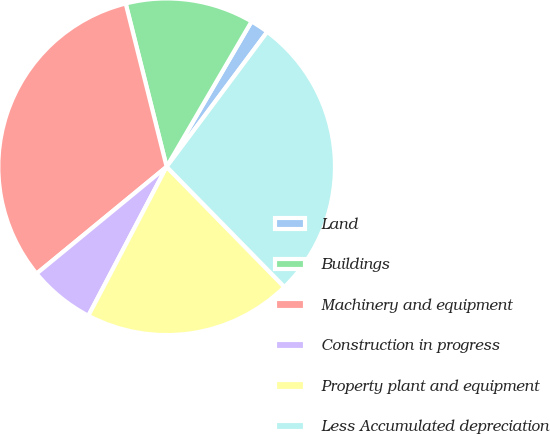Convert chart to OTSL. <chart><loc_0><loc_0><loc_500><loc_500><pie_chart><fcel>Land<fcel>Buildings<fcel>Machinery and equipment<fcel>Construction in progress<fcel>Property plant and equipment<fcel>Less Accumulated depreciation<nl><fcel>1.78%<fcel>12.33%<fcel>32.04%<fcel>6.35%<fcel>20.04%<fcel>27.47%<nl></chart> 